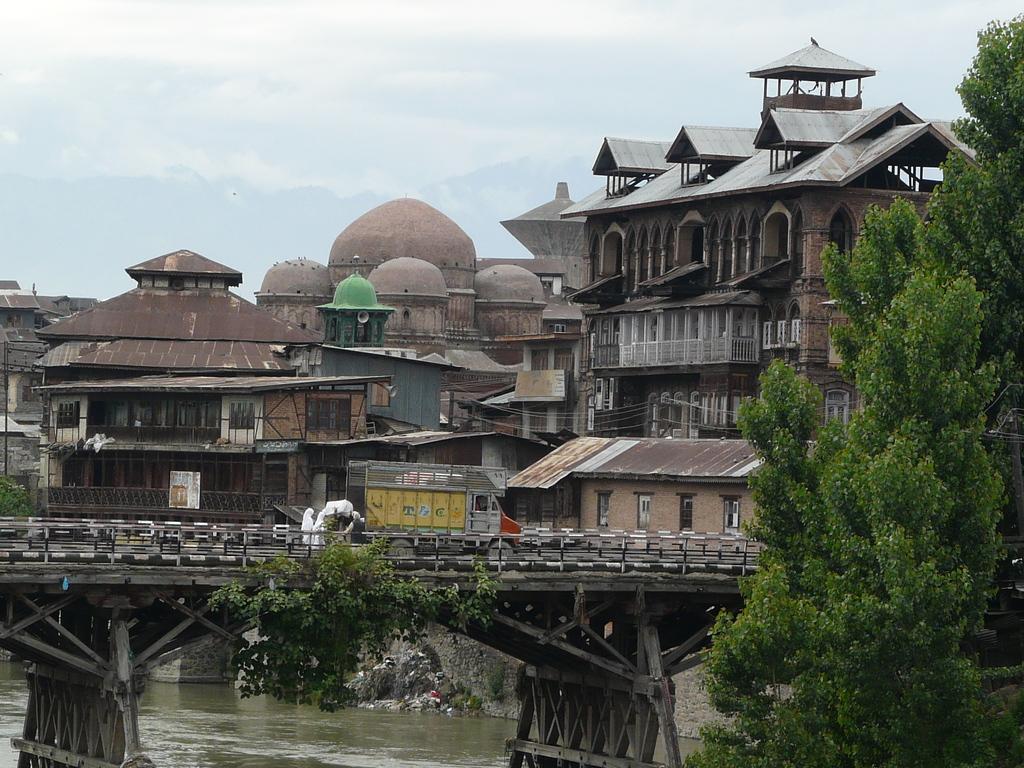Could you give a brief overview of what you see in this image? In this image I can see number of buildings, few trees, water and over the water I can see a bridge. I can also see a vehicle on the bridge. In the background I can see clouds and the sky. In the centre of the image I can see a speaker on the building. 